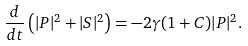Convert formula to latex. <formula><loc_0><loc_0><loc_500><loc_500>\frac { d } { d t } \left ( | P | ^ { 2 } + | S | ^ { 2 } \right ) = - 2 \gamma ( 1 + C ) | P | ^ { 2 } .</formula> 